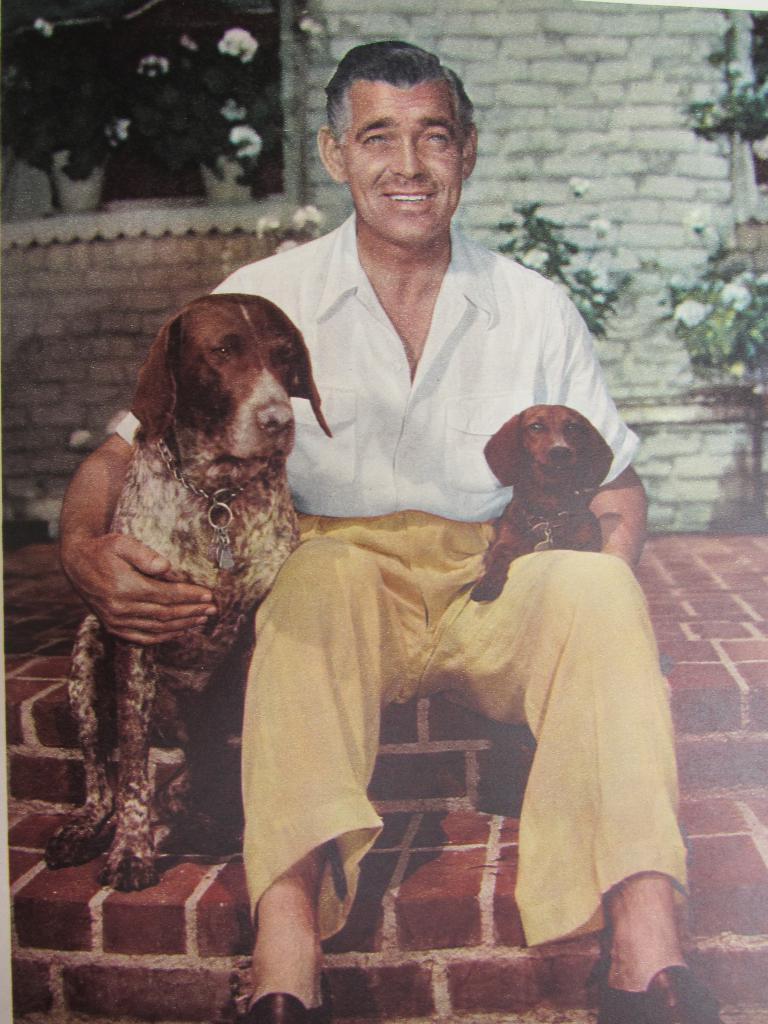Could you give a brief overview of what you see in this image? Here a man is sitting,holding 2 dogs on either side of his hands,behind him there is a wall and plants. 